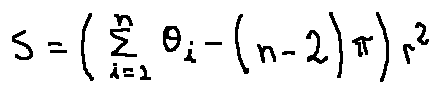Convert formula to latex. <formula><loc_0><loc_0><loc_500><loc_500>S = ( \sum \lim i t s _ { i = 1 } ^ { n } \theta _ { i } - ( n - 2 ) \pi ) r ^ { 2 }</formula> 